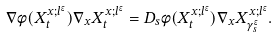Convert formula to latex. <formula><loc_0><loc_0><loc_500><loc_500>\nabla \phi ( X _ { t } ^ { x ; l ^ { \epsilon } } ) \nabla _ { x } X _ { t } ^ { x ; l ^ { \epsilon } } = D _ { s } \phi ( X _ { t } ^ { x ; l ^ { \epsilon } } ) \nabla _ { x } X _ { \gamma ^ { \epsilon } _ { s } } ^ { x ; l ^ { \epsilon } } .</formula> 